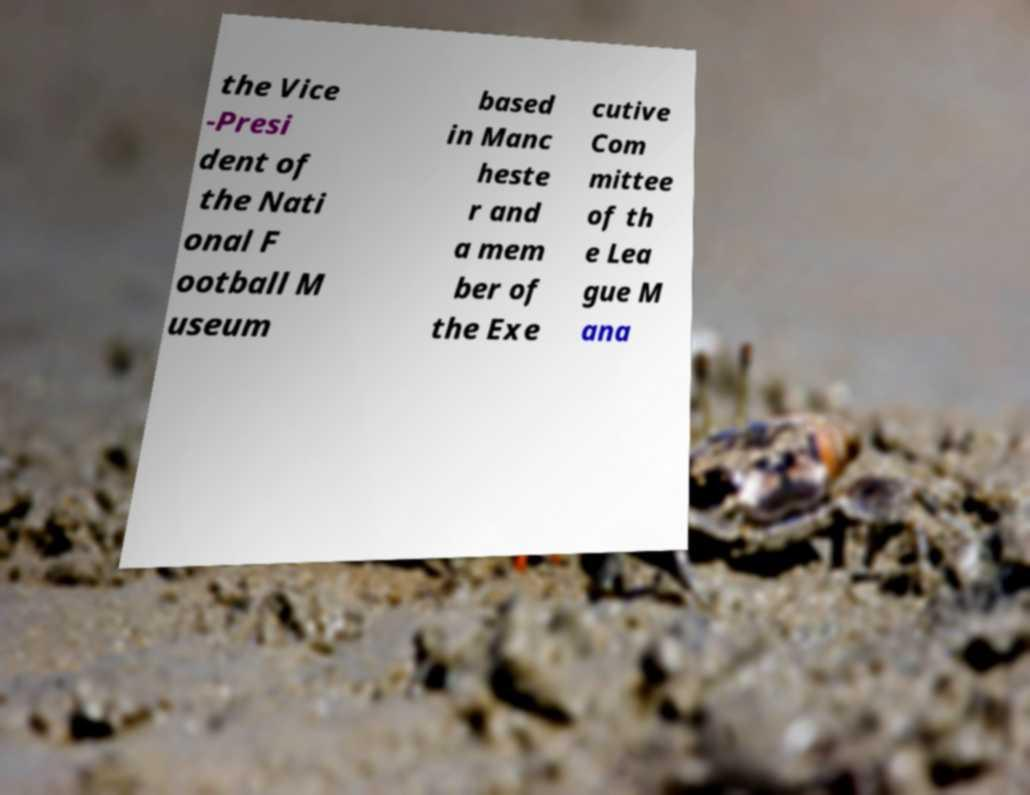Can you read and provide the text displayed in the image?This photo seems to have some interesting text. Can you extract and type it out for me? the Vice -Presi dent of the Nati onal F ootball M useum based in Manc heste r and a mem ber of the Exe cutive Com mittee of th e Lea gue M ana 